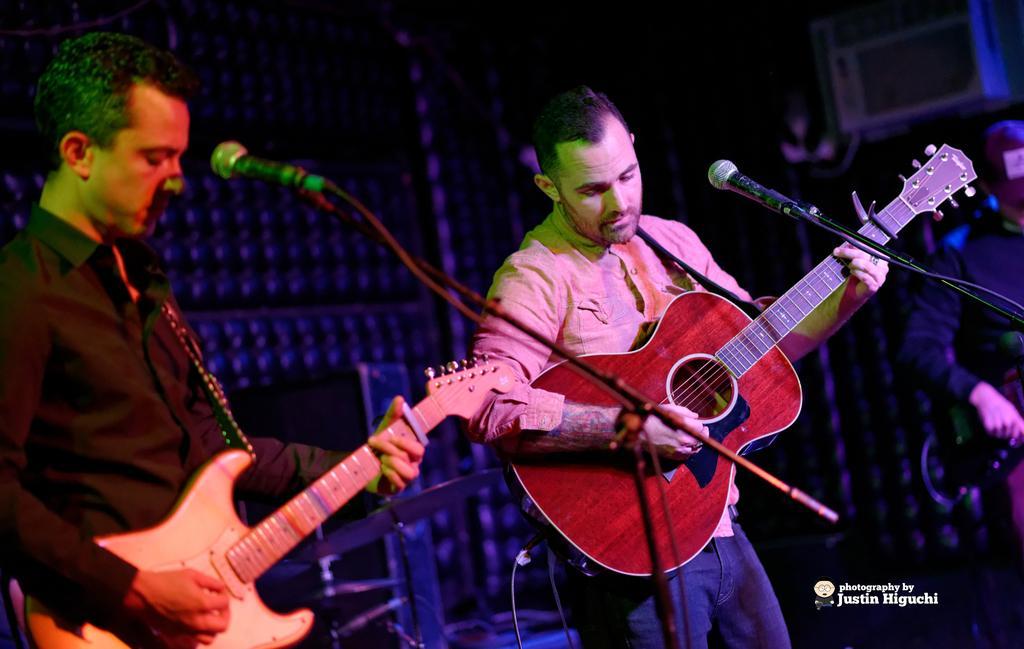Describe this image in one or two sentences. In this image I see 2 men who are holding the guitar and standing in front of a mic, In the background I see another person. 